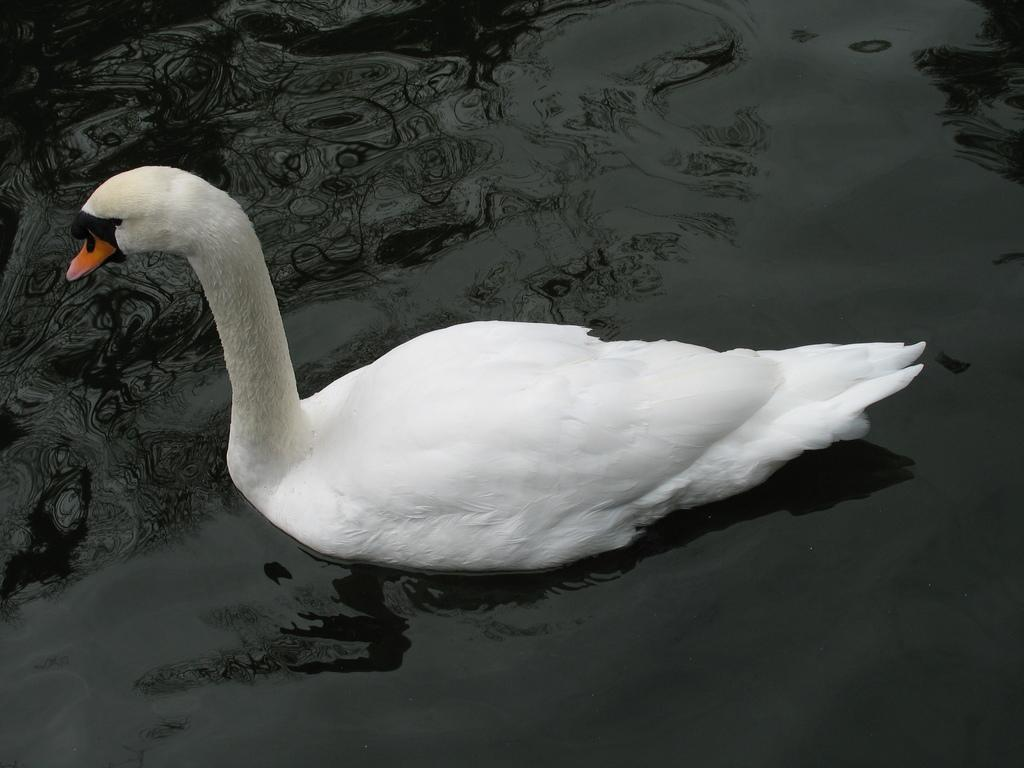What animal is present in the image? There is a swan in the image. Where is the swan located? The swan is on the surface of the water. What type of exchange is taking place between the swan and the corn in the image? There is no corn present in the image, and therefore no exchange can be observed. 